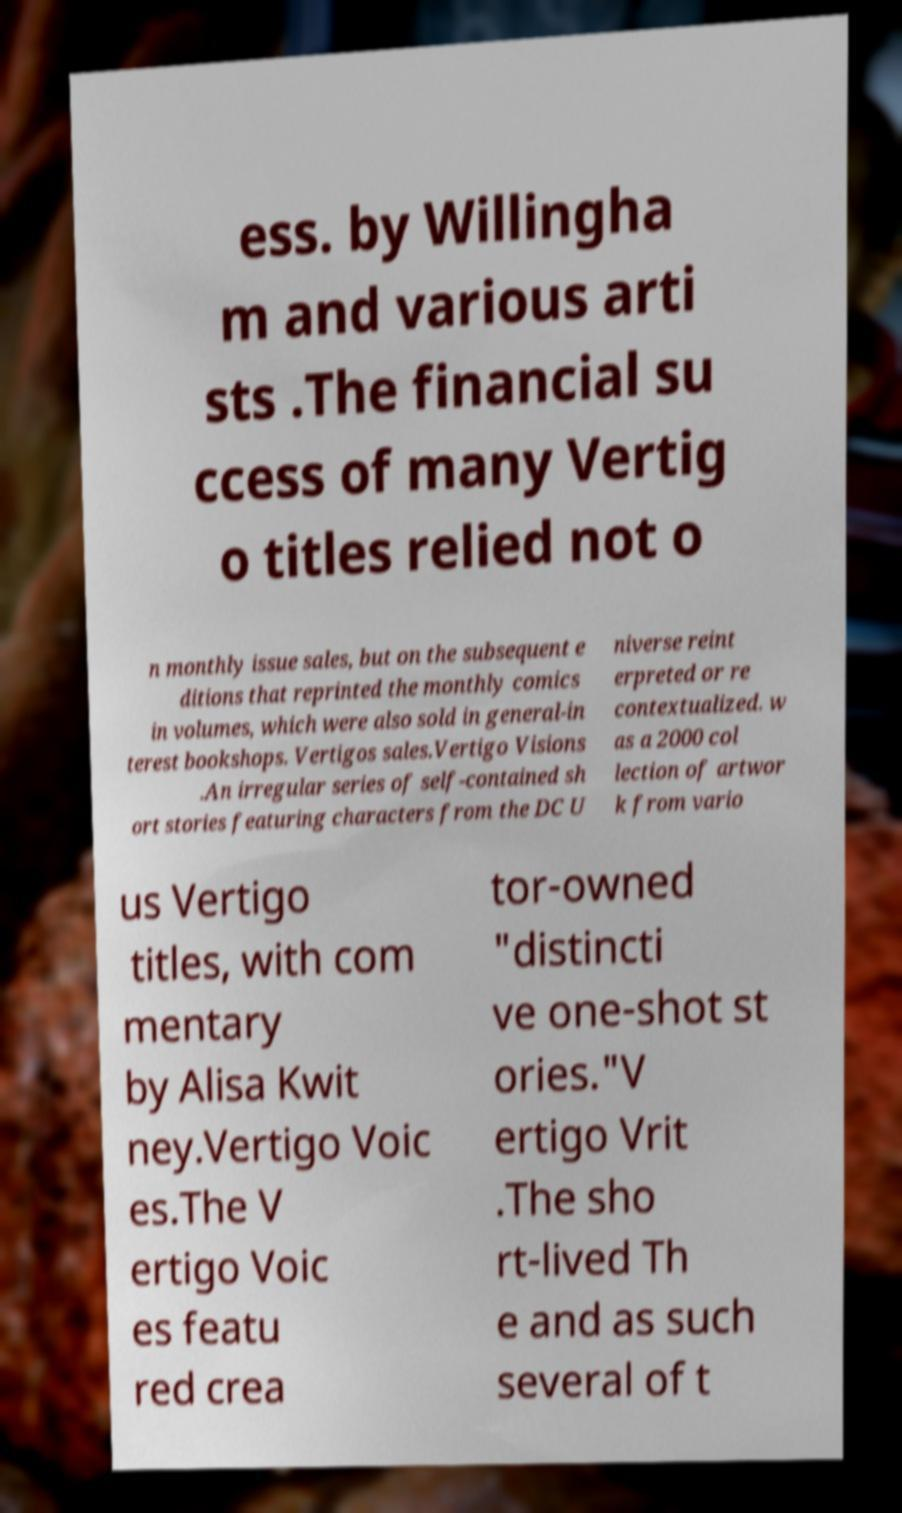Can you read and provide the text displayed in the image?This photo seems to have some interesting text. Can you extract and type it out for me? ess. by Willingha m and various arti sts .The financial su ccess of many Vertig o titles relied not o n monthly issue sales, but on the subsequent e ditions that reprinted the monthly comics in volumes, which were also sold in general-in terest bookshops. Vertigos sales.Vertigo Visions .An irregular series of self-contained sh ort stories featuring characters from the DC U niverse reint erpreted or re contextualized. w as a 2000 col lection of artwor k from vario us Vertigo titles, with com mentary by Alisa Kwit ney.Vertigo Voic es.The V ertigo Voic es featu red crea tor-owned "distincti ve one-shot st ories."V ertigo Vrit .The sho rt-lived Th e and as such several of t 